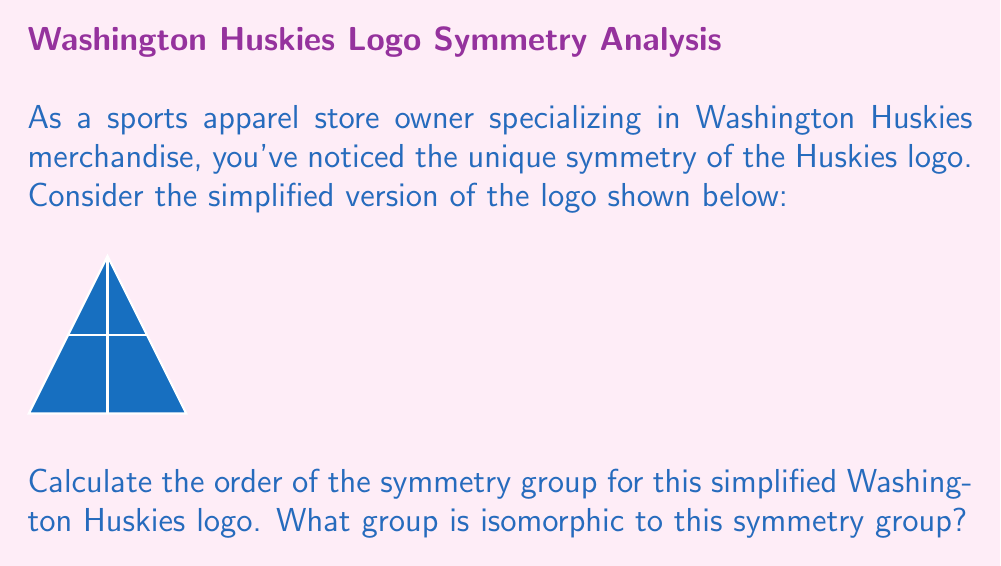Could you help me with this problem? Let's approach this step-by-step:

1) First, we need to identify all the symmetries of the logo:
   - Identity (do nothing)
   - Rotation by 180°
   - Reflection across the vertical axis
   - Reflection across the horizontal axis

2) These four symmetries form a group under composition. Let's call this group $G$.

3) To determine which group $G$ is isomorphic to, we need to understand its structure:
   - It has 4 elements
   - Each element is its own inverse
   - The composition of any two non-identity elements gives the third non-identity element

4) These properties match those of the Klein four-group, denoted as $V_4$ or $\mathbb{Z}_2 \times \mathbb{Z}_2$.

5) We can verify this by constructing the group table:

   $$\begin{array}{c|cccc}
   * & e & r & h & v \\
   \hline
   e & e & r & h & v \\
   r & r & e & v & h \\
   h & h & v & e & r \\
   v & v & h & r & e
   \end{array}$$

   Where $e$ is the identity, $r$ is rotation, $h$ is horizontal reflection, and $v$ is vertical reflection.

6) This table is indeed identical to that of $V_4$, confirming our isomorphism.

Therefore, the symmetry group of the simplified Washington Huskies logo has order 4 and is isomorphic to the Klein four-group.
Answer: $|G| = 4$, $G \cong V_4$ 